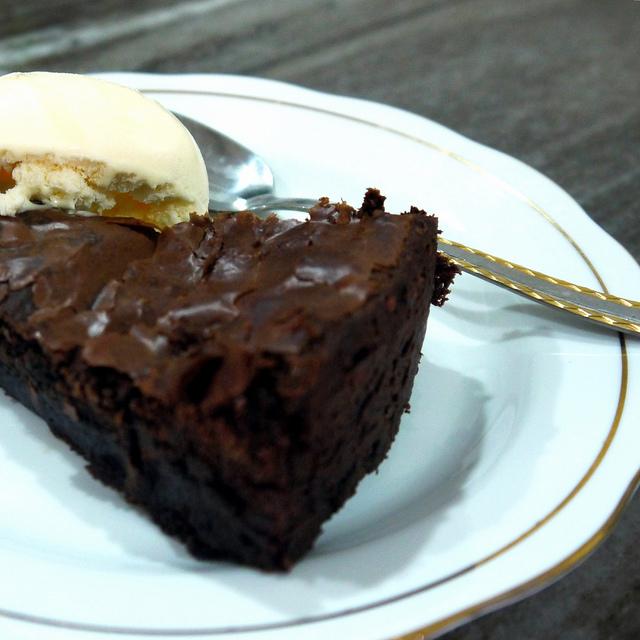What utensil in on the plate?
Write a very short answer. Spoon. What is this dessert?
Keep it brief. Chocolate cake. What color is the food item on the plate?
Be succinct. Brown. What color is the cake on the plate?
Give a very brief answer. Brown. 